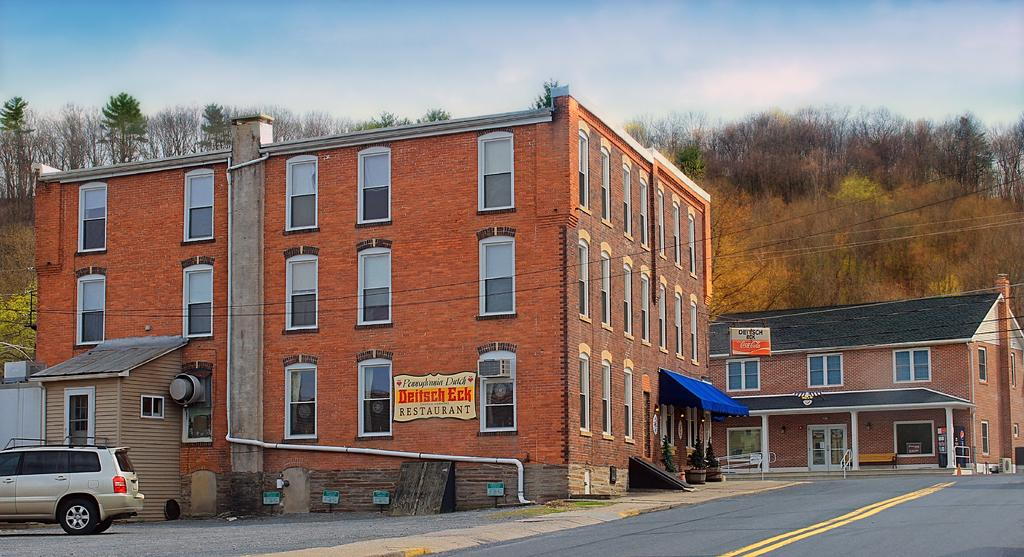What is the main subject in the center of the image? There are buildings in the center of the image. What can be seen on the right side of the image? There is a road on the right side of the image. What is located on the left side of the image? There is a car on the left side of the image. What type of natural scenery is visible in the background of the image? There are trees in the background of the image. What else can be seen in the background of the image? The sky is visible in the background of the image. What type of beast can be seen making a discovery with an instrument in the image? There is no beast or discovery with an instrument present in the image. 